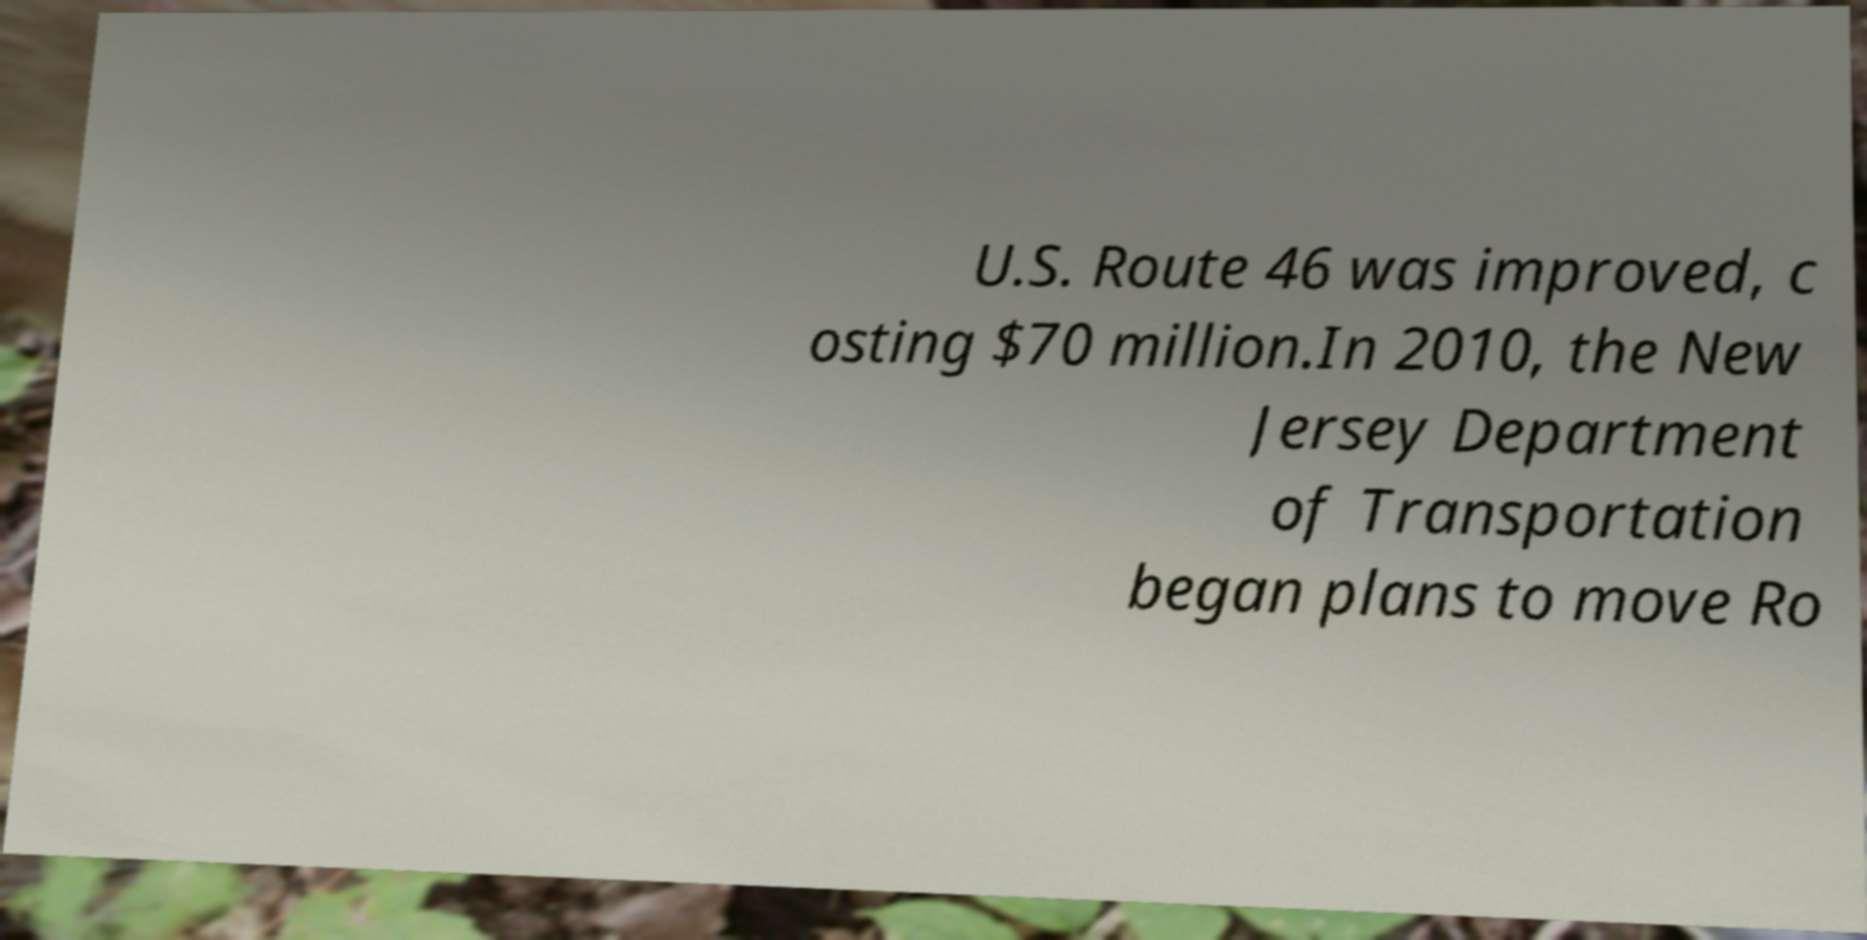What messages or text are displayed in this image? I need them in a readable, typed format. U.S. Route 46 was improved, c osting $70 million.In 2010, the New Jersey Department of Transportation began plans to move Ro 